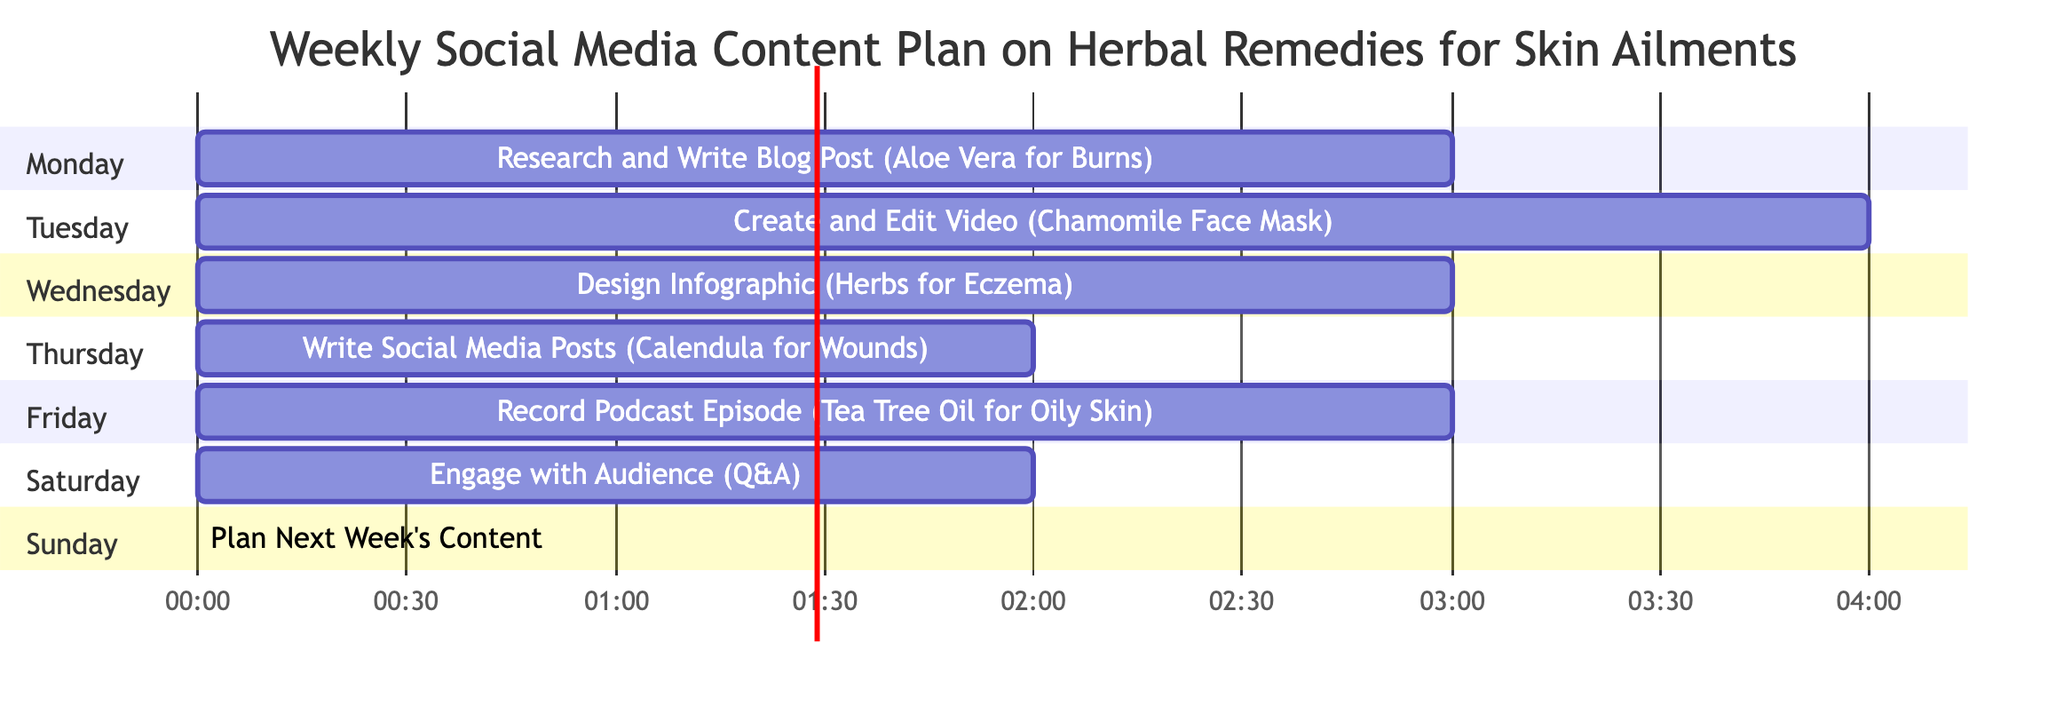What is the first task scheduled for Monday? The diagram lists "Research and Write Blog Post" as the first task under Monday, with a specified content focus on "Benefits of Aloe Vera for Skin Burns."
Answer: Research and Write Blog Post How many hours are allocated for creating the video on Tuesday? On Tuesday, the task is "Create and Edit Video," which has a duration of 4 hours noted in the diagram.
Answer: 4 hours What is the total duration of tasks scheduled for Saturday? Saturday includes one task, "Engage with Audience," that takes 2 hours. Thus, the total duration of tasks for that day is simply the duration of that one task.
Answer: 2 hours Which task has the same duration as the one on Thursday? The task on Thursday is "Write Social Media Posts," which has a duration of 2 hours. The same duration is allocated to the task on Saturday, "Engage with Audience."
Answer: Engage with Audience What is the last task to be completed in this weekly plan? The last task is on Sunday, identified as "Plan Next Week's Content," which concludes the weekly plan.
Answer: Plan Next Week's Content Which day features a task focused on a podcast? The task involving a podcast is scheduled for Friday, where "Record Podcast Episode" is noted in the diagram.
Answer: Friday How many total tasks are planned for the week? The diagram outlines one task for each day from Monday to Sunday, resulting in a total of 7 distinct tasks for the week.
Answer: 7 tasks What is the content focus of the task designed for Wednesday? The task for Wednesday is "Design Infographic" with a content focus on "Top 5 Herbs for Treating Eczema," as indicated in the diagram.
Answer: Top 5 Herbs for Treating Eczema 